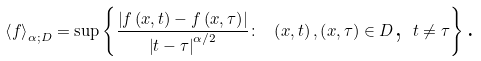Convert formula to latex. <formula><loc_0><loc_0><loc_500><loc_500>\left \langle f \right \rangle _ { \alpha ; D } = \sup \left \{ \frac { \left | f \left ( x , t \right ) - f \left ( x , \tau \right ) \right | } { \left | t - \tau \right | ^ { \alpha / 2 } } \colon \text { } \left ( x , t \right ) , \left ( x , \tau \right ) \in D \text {, } t \neq \tau \right \} \text {.}</formula> 